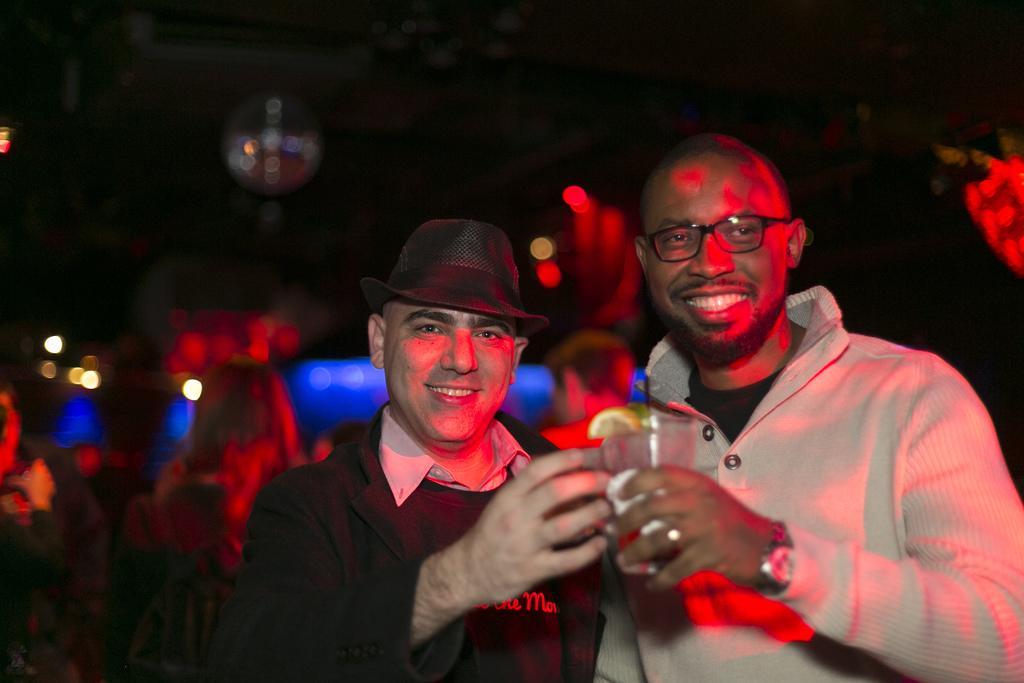Can you describe this image briefly? In this image in the foreground there are two persons who are standing and one person is holding a glass, and in the background there are some people who are sitting and some lights and wall. 